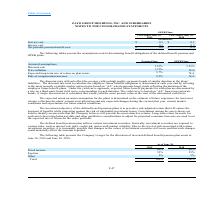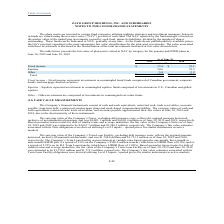According to Zayo Group Holdings's financial document, What types of risks are investment securities exposed to? Generally, investment securities are exposed to various risks, such as interest rate risks, credit risk, and overall market volatility.. The document states: "nsion plan utilizes various investment securities. Generally, investment securities are exposed to various risks, such as interest rate risks, credit ..." Also, Why is it possible that changes in the values of investment securities will occur? Due to the level of risk associated with certain investment securities, it is reasonably possible that changes in the values of investment securities will occur. The document states: "isks, credit risk, and overall market volatility. Due to the level of risk associated with certain investment securities, it is reasonably possible th..." Also, What was the company's target for the allocation of fixed income at June 30, 2019? According to the financial document, 40%. The relevant text states: "Fixed income 40% 40%..." Additionally, Which pension plan assets had the highest allocation at June 30, 2019? According to the financial document, Equities. The relevant text states: "Equities 55% 55%..." Also, can you calculate: What was the proportion of equities to fixed income for 2018? Based on the calculation: 55%/40%, the result is 137.5 (percentage). This is based on the information: "Fixed income 40% 40% Equities 55% 55%..." The key data points involved are: 40, 55. Also, can you calculate: What is the change in the allocation of equities from 2018 to 2019? I cannot find a specific answer to this question in the financial document. 